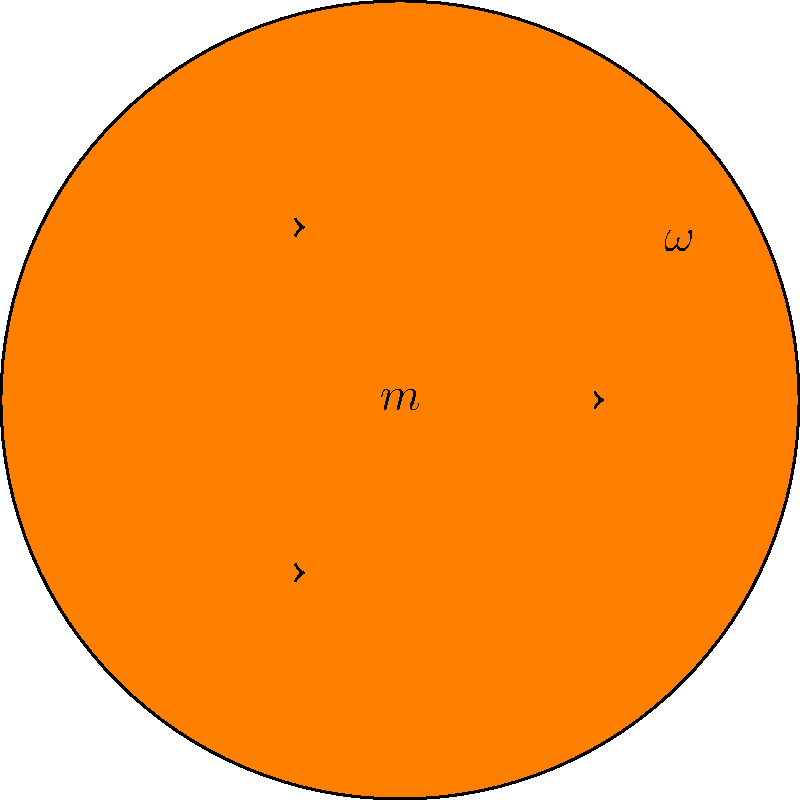During the NBA Finals, you notice a basketball spinning at 5 revolutions per second. If the basketball has a mass of 0.62 kg and a radius of 12 cm, what is its angular momentum? Assume the basketball can be treated as a solid sphere. To find the angular momentum of the spinning basketball, we'll follow these steps:

1) The formula for angular momentum (L) is:
   $$L = I\omega$$
   where I is the moment of inertia and $\omega$ is the angular velocity.

2) For a solid sphere, the moment of inertia is:
   $$I = \frac{2}{5}mr^2$$
   where m is the mass and r is the radius.

3) Let's calculate I:
   $$I = \frac{2}{5} \times 0.62 \text{ kg} \times (0.12 \text{ m})^2 = 0.001785 \text{ kg}\cdot\text{m}^2$$

4) Now we need to convert the rotation speed to angular velocity in rad/s:
   $$\omega = 2\pi \times 5 \text{ rev/s} = 31.4159 \text{ rad/s}$$

5) Now we can calculate the angular momentum:
   $$L = I\omega = 0.001785 \text{ kg}\cdot\text{m}^2 \times 31.4159 \text{ rad/s} = 0.0561 \text{ kg}\cdot\text{m}^2/\text{s}$$

6) Rounding to three significant figures:
   $$L \approx 0.0561 \text{ kg}\cdot\text{m}^2/\text{s}$$
Answer: $0.0561 \text{ kg}\cdot\text{m}^2/\text{s}$ 